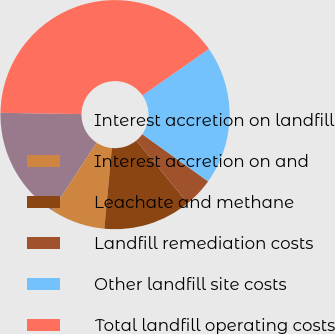<chart> <loc_0><loc_0><loc_500><loc_500><pie_chart><fcel>Interest accretion on landfill<fcel>Interest accretion on and<fcel>Leachate and methane<fcel>Landfill remediation costs<fcel>Other landfill site costs<fcel>Total landfill operating costs<nl><fcel>16.03%<fcel>7.74%<fcel>12.44%<fcel>4.15%<fcel>19.62%<fcel>40.03%<nl></chart> 